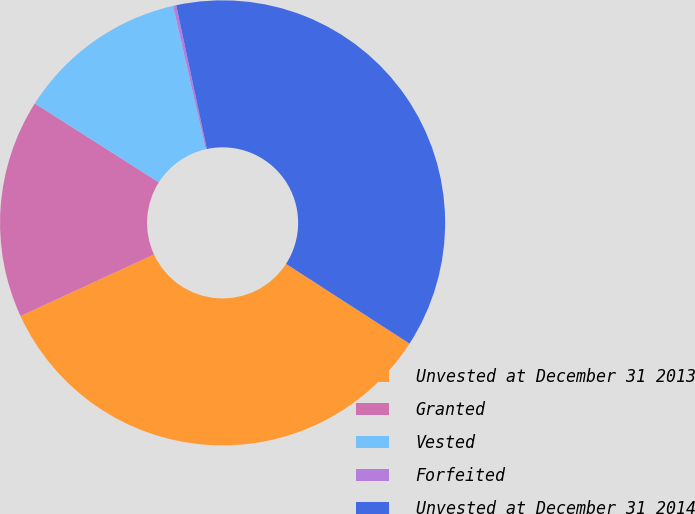Convert chart. <chart><loc_0><loc_0><loc_500><loc_500><pie_chart><fcel>Unvested at December 31 2013<fcel>Granted<fcel>Vested<fcel>Forfeited<fcel>Unvested at December 31 2014<nl><fcel>34.0%<fcel>15.89%<fcel>12.41%<fcel>0.23%<fcel>37.47%<nl></chart> 